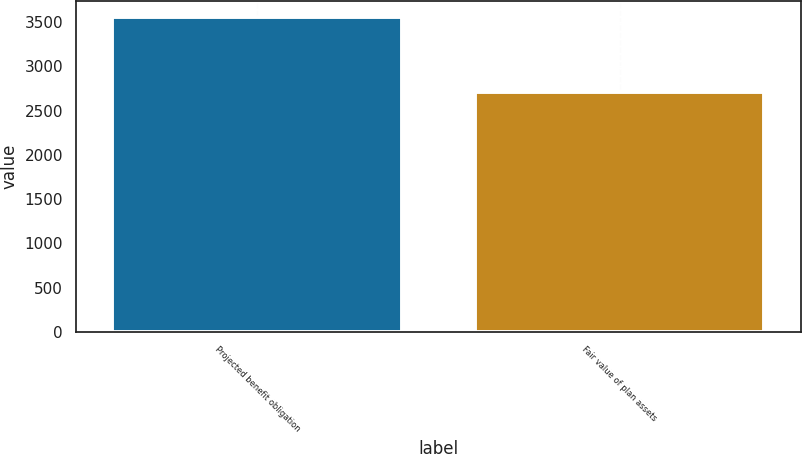Convert chart. <chart><loc_0><loc_0><loc_500><loc_500><bar_chart><fcel>Projected benefit obligation<fcel>Fair value of plan assets<nl><fcel>3559<fcel>2711<nl></chart> 